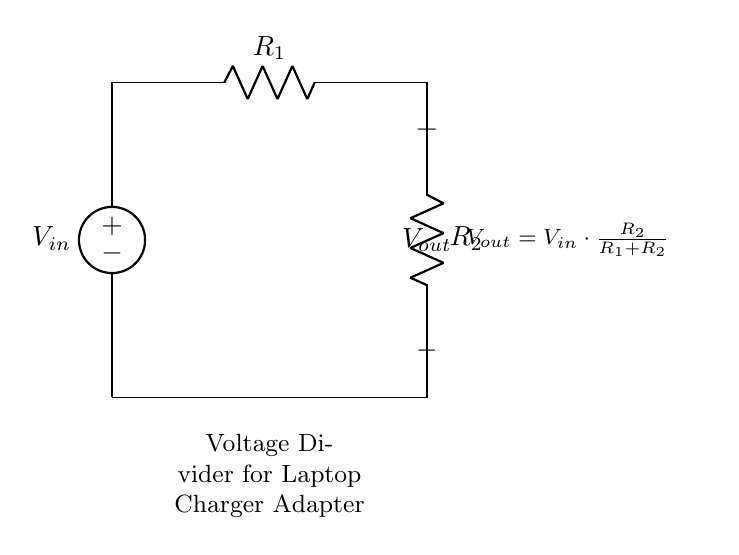What components are in this circuit? The circuit includes a voltage source, two resistors labeled R1 and R2.
Answer: voltage source, R1, R2 What is the output voltage formula? The output voltage is calculated using the formula: output voltage equals input voltage times the ratio of R2 to the sum of R1 and R2.
Answer: Vout = Vin * (R2 / (R1 + R2)) What type of circuit is this? This is a voltage divider circuit, specifically used for lowering voltage levels.
Answer: voltage divider circuit What do R1 and R2 represent? R1 and R2 represent resistors in the circuit that divide the input voltage.
Answer: resistors If R1 = 2 ohms and R2 = 3 ohms, what is the ratio used in calculating Vout? The ratio of R2 to R1 plus R2 is calculated as 3 divided by 5, which gives a ratio of 0.6.
Answer: 0.6 What is Vout if Vin is 10 volts with the given R1 and R2 values? Using the voltage divider formula, Vout equals 10 volts times the ratio calculated previously, yielding a Vout of 6 volts.
Answer: 6 volts 